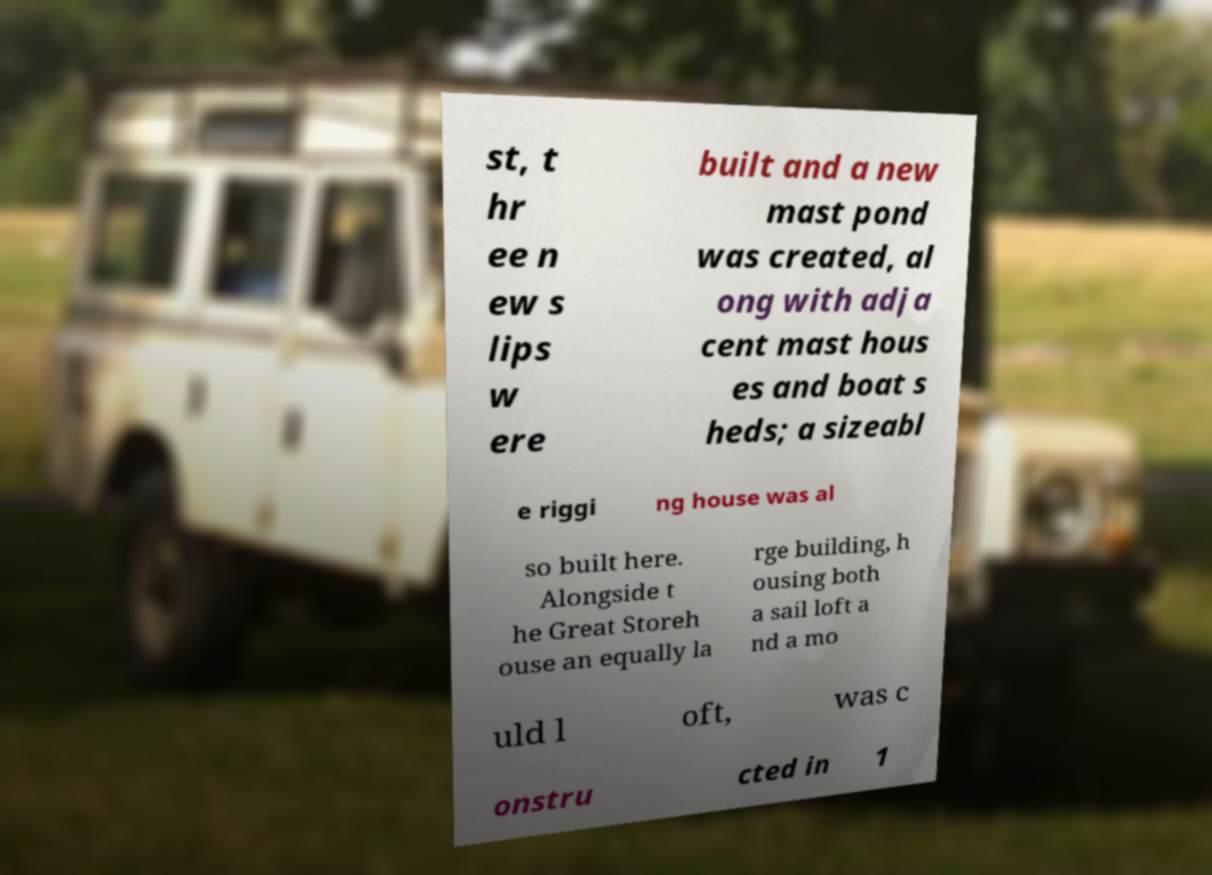Please read and relay the text visible in this image. What does it say? st, t hr ee n ew s lips w ere built and a new mast pond was created, al ong with adja cent mast hous es and boat s heds; a sizeabl e riggi ng house was al so built here. Alongside t he Great Storeh ouse an equally la rge building, h ousing both a sail loft a nd a mo uld l oft, was c onstru cted in 1 